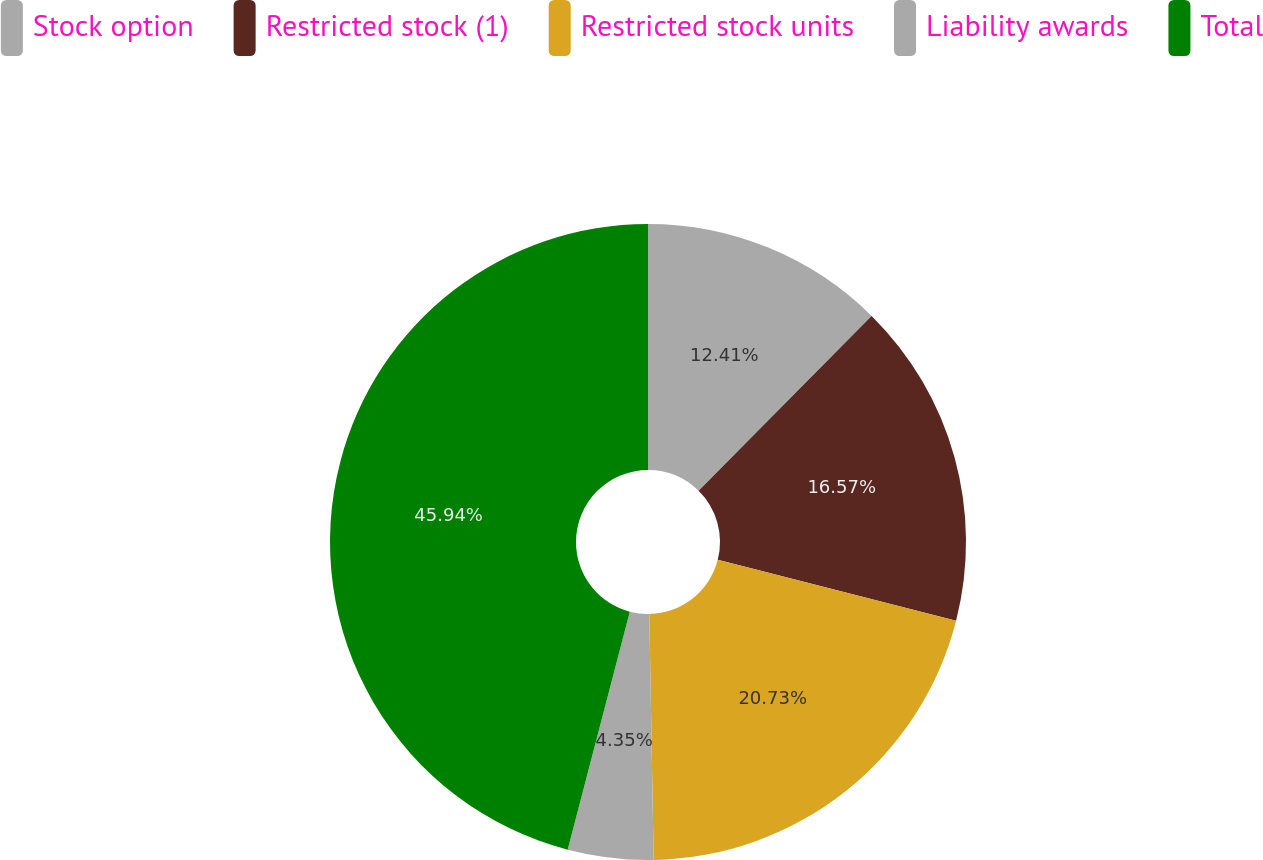<chart> <loc_0><loc_0><loc_500><loc_500><pie_chart><fcel>Stock option<fcel>Restricted stock (1)<fcel>Restricted stock units<fcel>Liability awards<fcel>Total<nl><fcel>12.41%<fcel>16.57%<fcel>20.73%<fcel>4.35%<fcel>45.93%<nl></chart> 